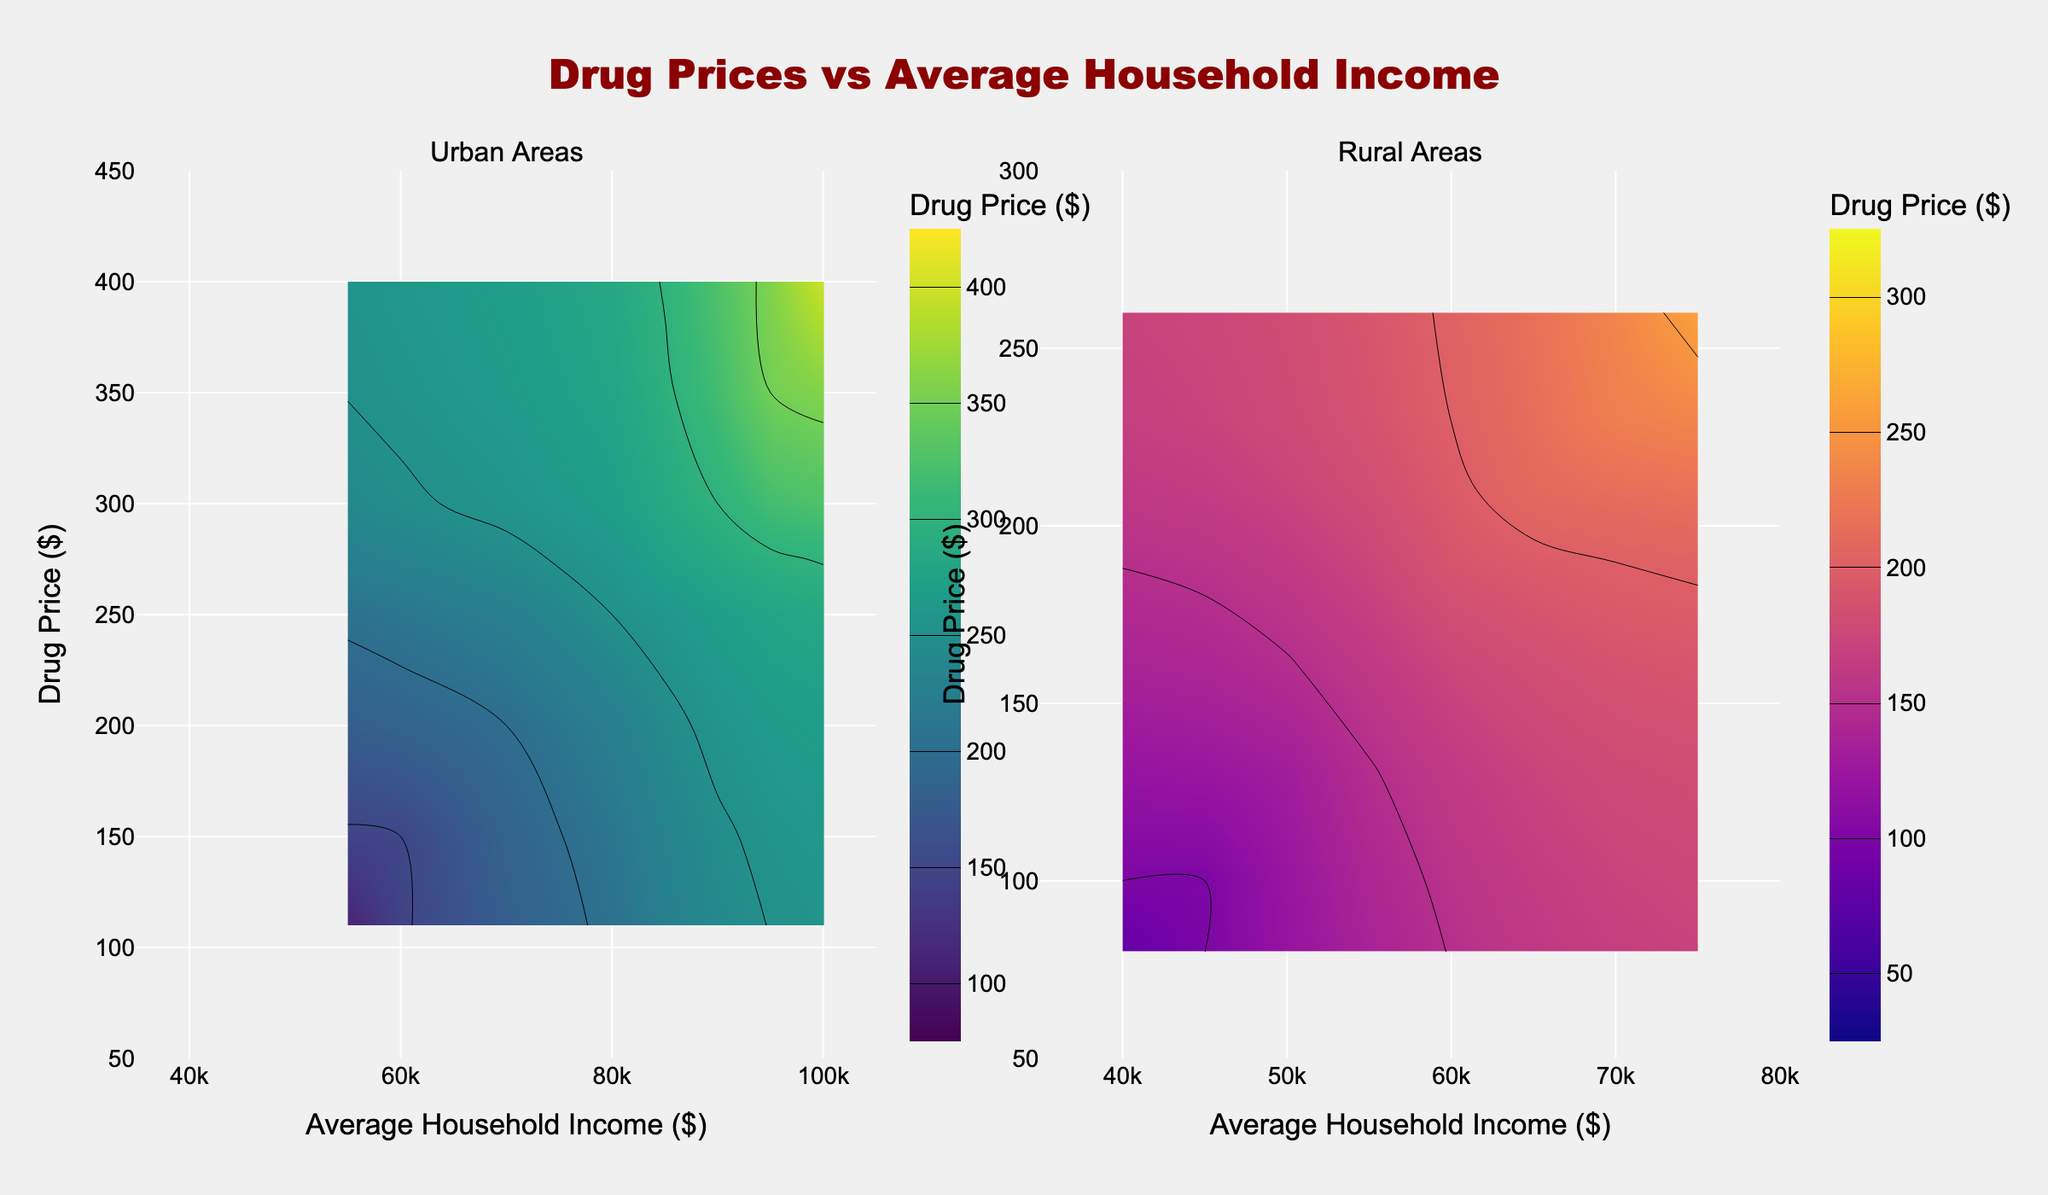What's the title of the figure? The title is prominently displayed at the top of the figure, it reads "Drug Prices vs Average Household Income".
Answer: Drug Prices vs Average Household Income How many subplots are in the figure? The figure is divided into two subplots, clearly indicated by the additional titles "Urban Areas" and "Rural Areas" above each subplot.
Answer: Two What is the range of Drug Prices in Urban Areas? In the Urban subplot, the y-axis label "Drug Price ($)" shows the range, which extends from 50 to 450 dollars.
Answer: 50 to 450 dollars Which subplot uses the 'Viridis' color scale? By examining the figure, you can see that the 'Viridis' color scale is used in the Urban Areas subplot as described in the legend located within the corresponding subplot.
Answer: Urban Areas Compare the start and end values of the Drug Price contours for Rural and Urban areas. Inspecting the color bars and contour lines, the Urban contours start at $100 and end at $400, while the Rural contours start at $50 and end at $300.
Answer: Urban: $100 to $400, Rural: $50 to $300 Which region has a higher maximum average household income? Observing the x-axis labels, Urban areas reach a maximum average household income of $100,000, while Rural areas reach $75,000. Thus, Urban areas have a higher maximum.
Answer: Urban areas Is there a correlation between Drug Prices and Avg Household Income in Rural areas based on the contour plot? The contours show that as average household income increases, drug prices in Rural areas also generally increase. This suggests a positive correlation.
Answer: Yes, positive correlation What is the color of the highest drug price region in Urban Areas? Observing the 'Viridis' color scale used, the highest drug price areas are represented by the brightest or most intense shades, often towards the yellow part of the scale.
Answer: Yellow What is the lowest average household income range displayed for Urban and Rural Areas? The x-axis for both subplots shows the lowest average household income starting at $35,000.
Answer: $35,000 Which area shows a sharper increase in drug prices as household income increases, Urban or Rural? The contours in the Urban subplot are more densely packed, indicating a sharper increase in drug prices with household income compared to the Rural subplot.
Answer: Urban 